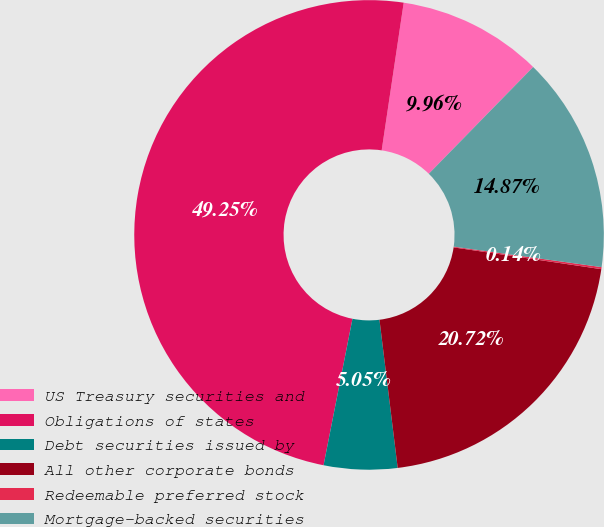<chart> <loc_0><loc_0><loc_500><loc_500><pie_chart><fcel>US Treasury securities and<fcel>Obligations of states<fcel>Debt securities issued by<fcel>All other corporate bonds<fcel>Redeemable preferred stock<fcel>Mortgage-backed securities<nl><fcel>9.96%<fcel>49.25%<fcel>5.05%<fcel>20.72%<fcel>0.14%<fcel>14.87%<nl></chart> 